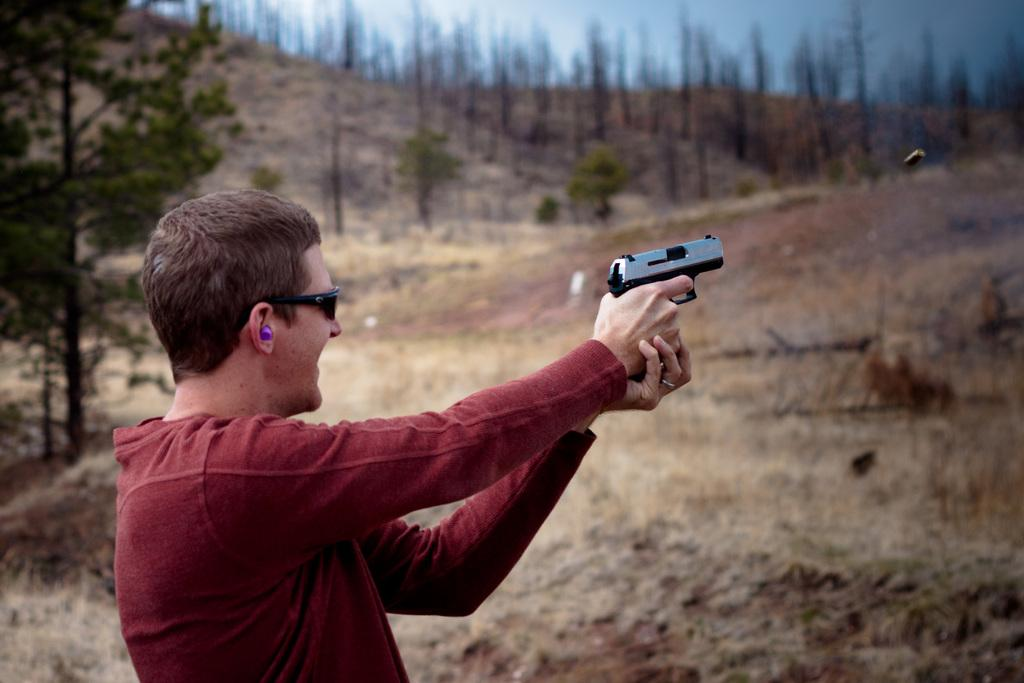What is the main subject of the image? There is a person in the image. What is the person wearing? The person is wearing goggles. What is the person holding? The person is holding a gun. What can be seen in the background of the image? There are trees and the sky visible in the background of the image. How is the background of the image depicted? The background is blurred. What type of skin condition can be seen on the person's face in the image? There is no indication of a skin condition on the person's face in the image. What effect does the desk have on the person's ability to hold the gun in the image? There is no desk present in the image, so it cannot have any effect on the person's ability to hold the gun. 